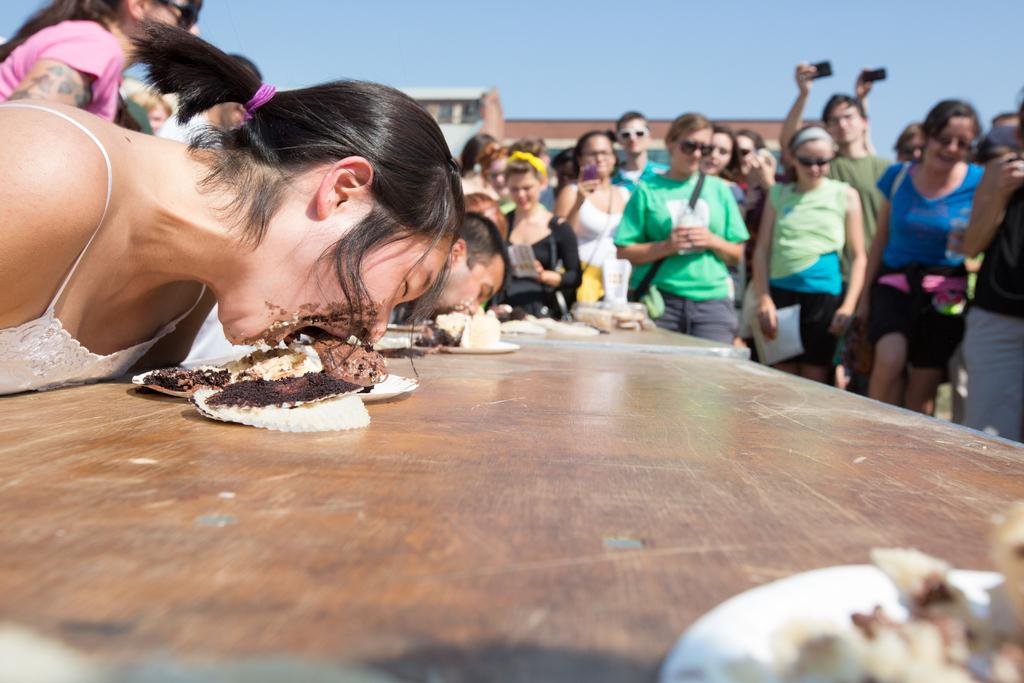How many people are present in the image? There are people in the image, but the exact number is not specified. What are two people doing in the image? Two people are eating food items in the image. Where are the food items placed? The food items are on plates, which are on a table. What can be seen in the background of the image? There is a building and the sky visible in the background of the image. What historical event is being commemorated by the people in the image? There is no indication of a historical event being commemorated in the image. Can you see a match being used by the people in the image? There is no match present in the image. 